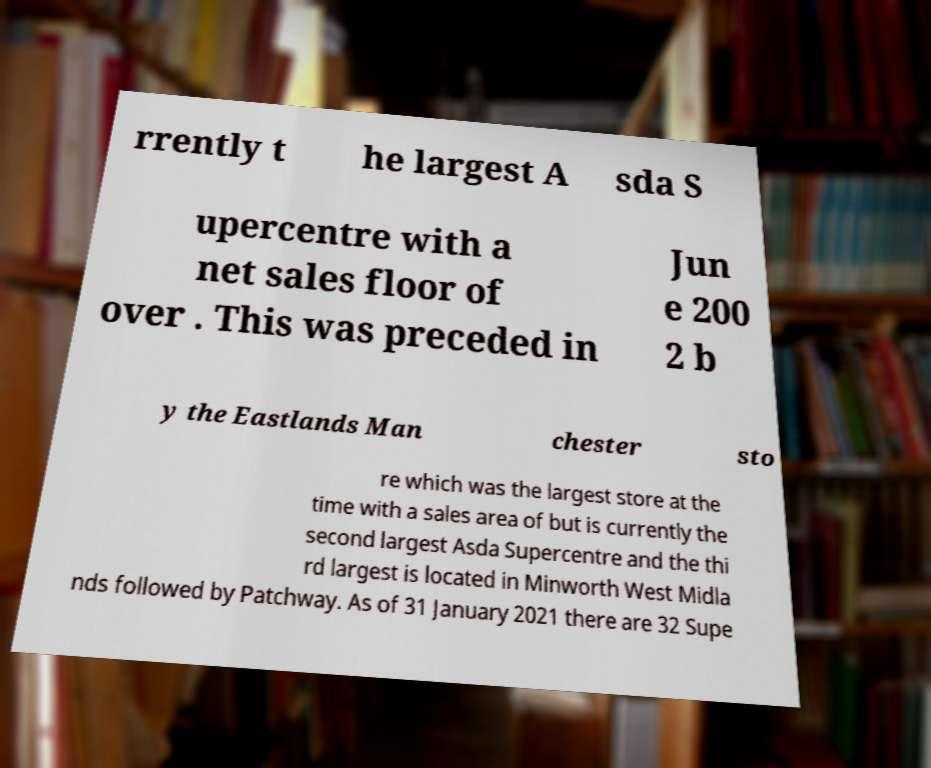I need the written content from this picture converted into text. Can you do that? rrently t he largest A sda S upercentre with a net sales floor of over . This was preceded in Jun e 200 2 b y the Eastlands Man chester sto re which was the largest store at the time with a sales area of but is currently the second largest Asda Supercentre and the thi rd largest is located in Minworth West Midla nds followed by Patchway. As of 31 January 2021 there are 32 Supe 